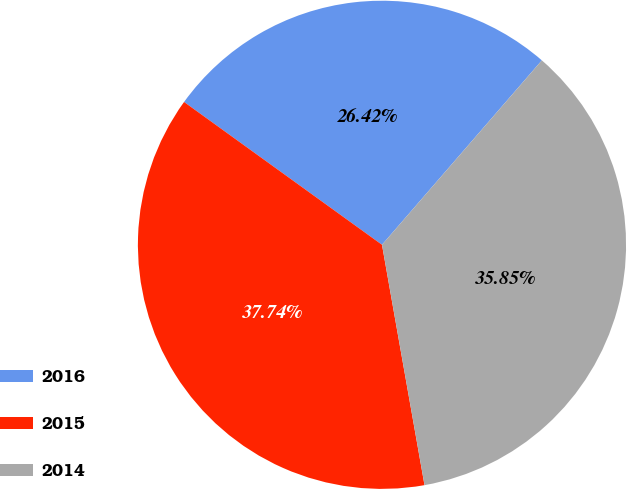Convert chart. <chart><loc_0><loc_0><loc_500><loc_500><pie_chart><fcel>2016<fcel>2015<fcel>2014<nl><fcel>26.42%<fcel>37.74%<fcel>35.85%<nl></chart> 